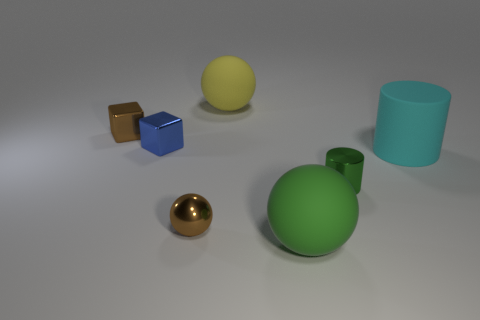There is another sphere that is the same size as the yellow matte sphere; what material is it?
Provide a short and direct response. Rubber. Are there an equal number of large cyan cylinders in front of the green shiny thing and tiny cyan metallic cylinders?
Make the answer very short. Yes. There is a large thing that is behind the big cyan thing; what is its color?
Provide a short and direct response. Yellow. How many other objects are there of the same color as the matte cylinder?
Ensure brevity in your answer.  0. Is the size of the shiny object that is on the right side of the green sphere the same as the green matte ball?
Make the answer very short. No. What is the cylinder that is in front of the large cyan rubber cylinder made of?
Your response must be concise. Metal. Are there any other things that are the same shape as the yellow rubber object?
Offer a very short reply. Yes. How many matte things are tiny green cylinders or large cyan cylinders?
Your response must be concise. 1. Are there fewer tiny objects to the right of the green ball than cubes?
Make the answer very short. Yes. What is the shape of the tiny thing that is right of the matte sphere to the right of the big sphere behind the small blue metal object?
Keep it short and to the point. Cylinder. 